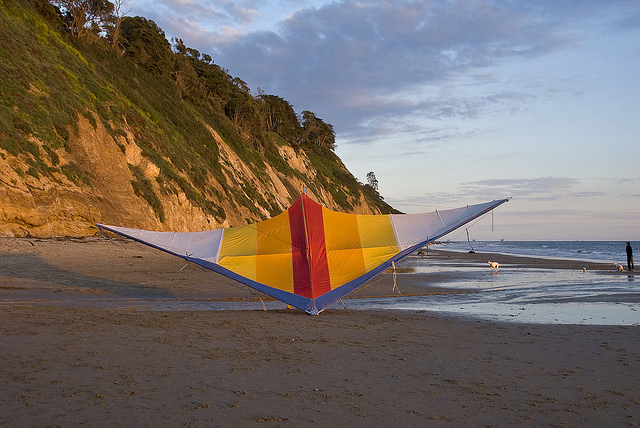What is the main object in the image? The central object in the image is a large, vibrant kite featuring bold colors, prominently displayed on a sandy beach. 